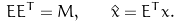Convert formula to latex. <formula><loc_0><loc_0><loc_500><loc_500>E E ^ { T } = M , \quad \hat { x } = E ^ { T } x .</formula> 